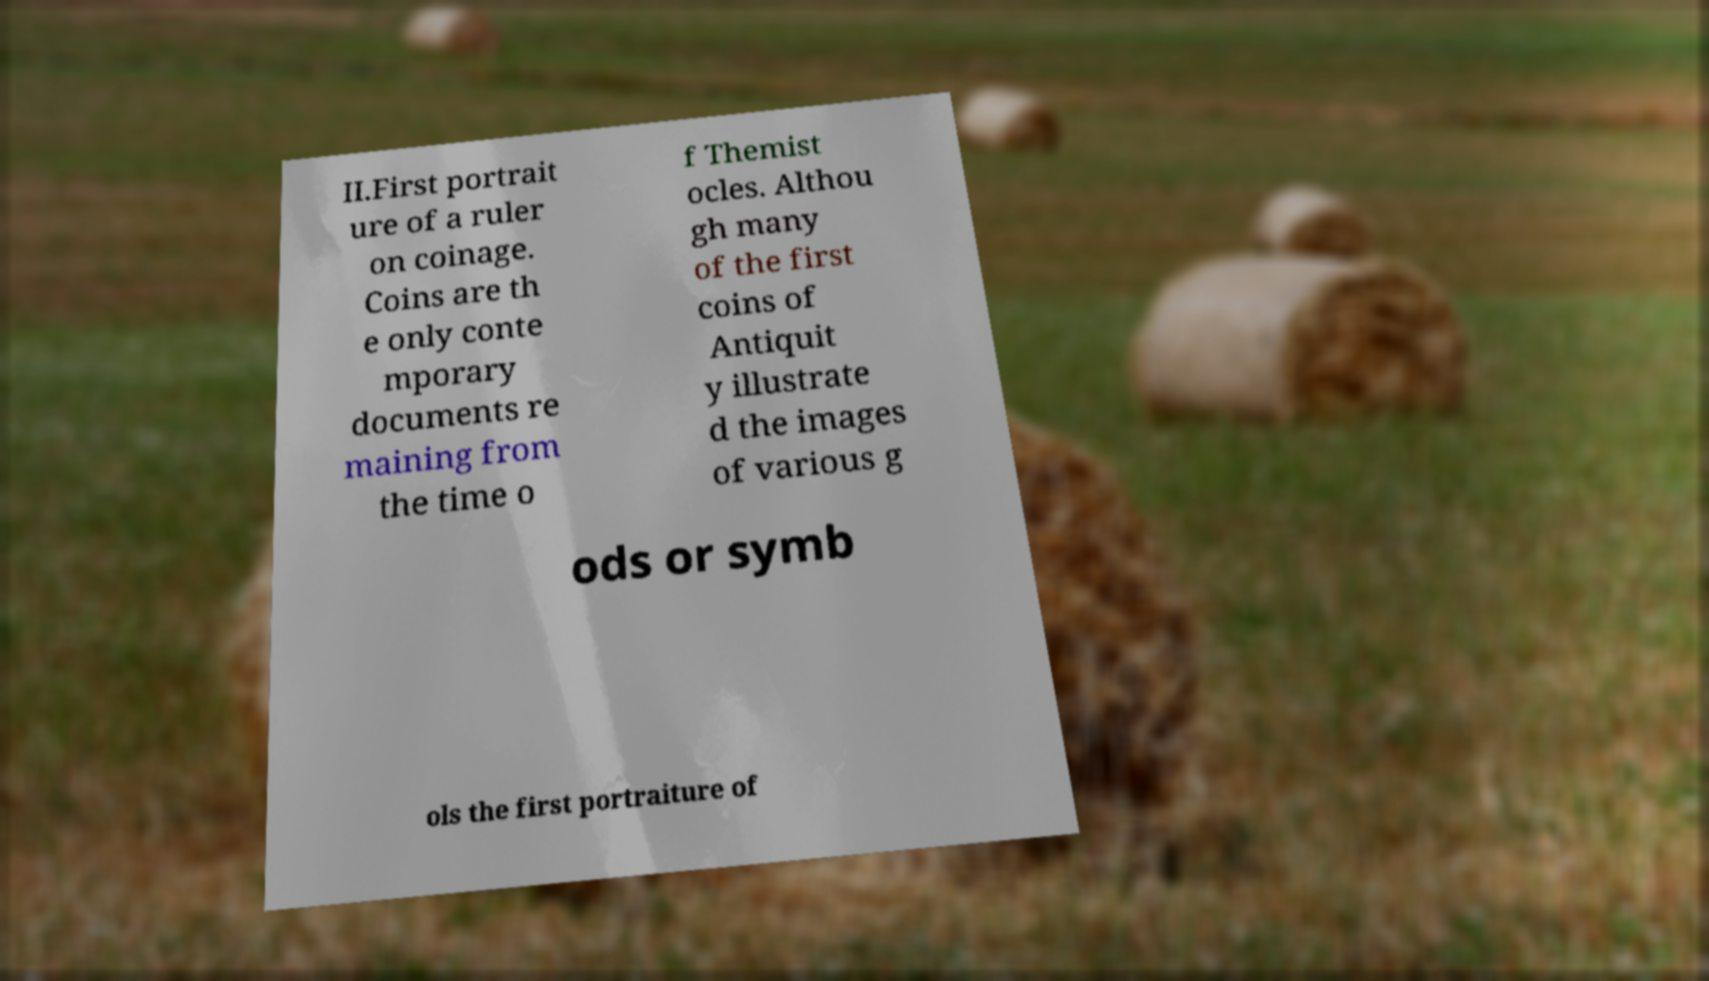Can you accurately transcribe the text from the provided image for me? II.First portrait ure of a ruler on coinage. Coins are th e only conte mporary documents re maining from the time o f Themist ocles. Althou gh many of the first coins of Antiquit y illustrate d the images of various g ods or symb ols the first portraiture of 